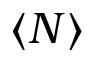Convert formula to latex. <formula><loc_0><loc_0><loc_500><loc_500>\langle N \rangle</formula> 